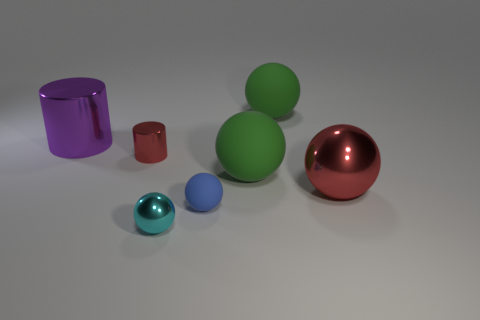If these objects were to be used in a physics demonstration, which two might best illustrate the concept of equilibrium? Assuming this demonstration aims to show static equilibrium, the large green sphere and the red sphere would serve well. Placed on a flat surface, they would both illustrate an object remaining at rest when not acted upon by an unbalanced force, as there's no indication of movement in the image. How would the reflection properties of the objects be relevant in such a demonstration? The reflective qualities of these objects might be used to discuss optics in physics. Observing how the light reflects and refracts off their surfaces could provide insights into the principles of light behavior, including specular reflection, which is particularly noticeable on these polished spheres and cylinders. 